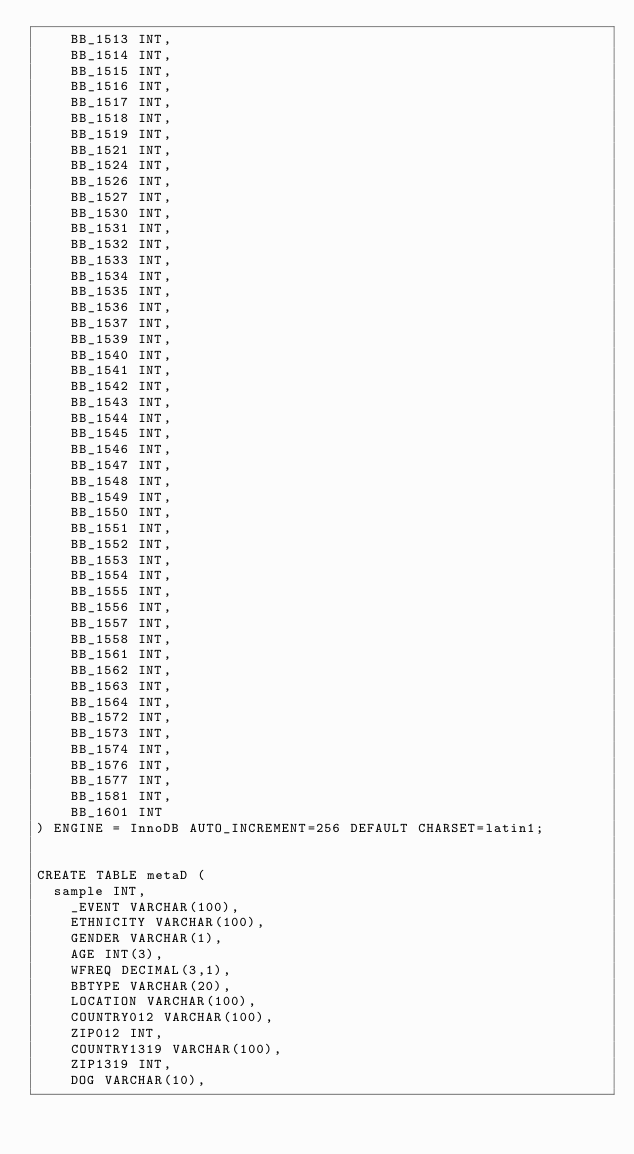<code> <loc_0><loc_0><loc_500><loc_500><_SQL_>    BB_1513 INT,
    BB_1514 INT,
    BB_1515 INT,
    BB_1516 INT,
    BB_1517 INT,
    BB_1518 INT,
    BB_1519 INT,
    BB_1521 INT,
    BB_1524 INT,
    BB_1526 INT,
    BB_1527 INT,
    BB_1530 INT,
    BB_1531 INT,
    BB_1532 INT,
    BB_1533 INT,
    BB_1534 INT,
    BB_1535 INT,
    BB_1536 INT,
    BB_1537 INT,
    BB_1539 INT,
    BB_1540 INT,
    BB_1541 INT,
    BB_1542 INT,
    BB_1543 INT,
    BB_1544 INT,
    BB_1545 INT,
    BB_1546 INT,
    BB_1547 INT,
    BB_1548 INT,
    BB_1549 INT,
    BB_1550 INT,
    BB_1551 INT,
    BB_1552 INT,
    BB_1553 INT,
    BB_1554 INT,
    BB_1555 INT,
    BB_1556 INT,
    BB_1557 INT,
    BB_1558 INT,
    BB_1561 INT,
    BB_1562 INT,
    BB_1563 INT,
    BB_1564 INT,
    BB_1572 INT,
    BB_1573 INT,
    BB_1574 INT,
    BB_1576 INT,
    BB_1577 INT,
    BB_1581 INT,
    BB_1601 INT
) ENGINE = InnoDB AUTO_INCREMENT=256 DEFAULT CHARSET=latin1;


CREATE TABLE metaD (
	sample INT,
    _EVENT VARCHAR(100),
    ETHNICITY VARCHAR(100),
    GENDER VARCHAR(1),
    AGE INT(3),
    WFREQ DECIMAL(3,1),
    BBTYPE VARCHAR(20),
    LOCATION VARCHAR(100),
    COUNTRY012 VARCHAR(100),
    ZIP012 INT,
    COUNTRY1319 VARCHAR(100),
    ZIP1319 INT,
    DOG VARCHAR(10),</code> 